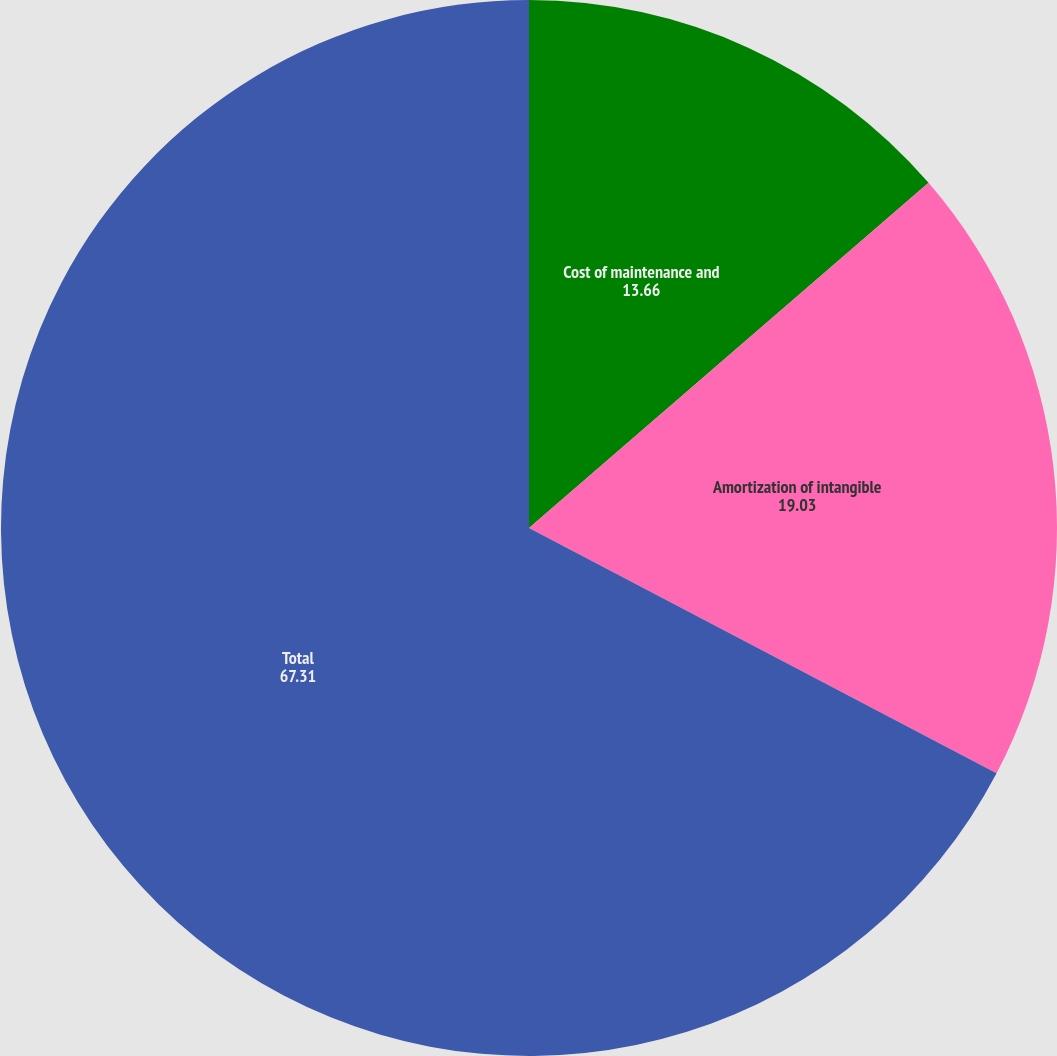Convert chart. <chart><loc_0><loc_0><loc_500><loc_500><pie_chart><fcel>Cost of maintenance and<fcel>Amortization of intangible<fcel>Total<nl><fcel>13.66%<fcel>19.03%<fcel>67.31%<nl></chart> 